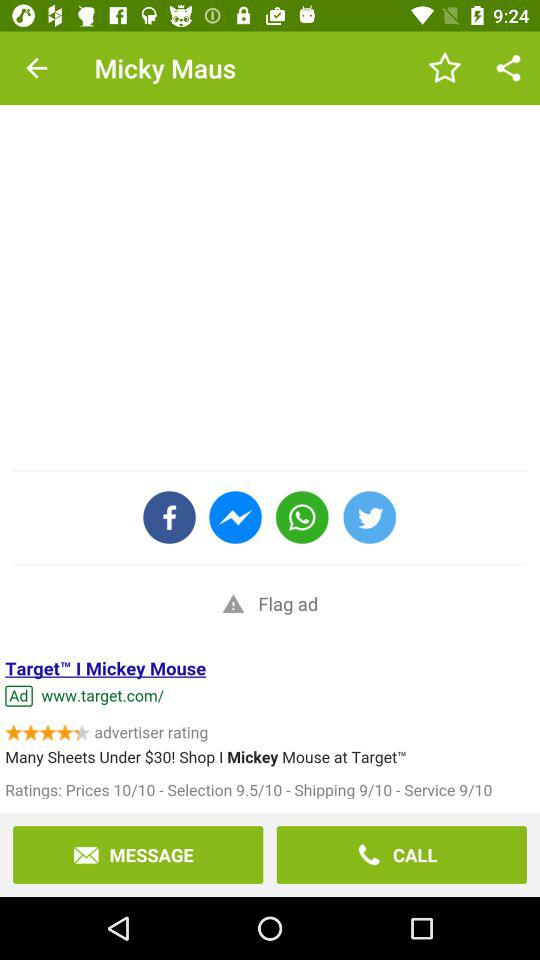Which applications can be used to share? The applications are "Facebook", "Messenger", "WhatsApp" and "Twitter". 